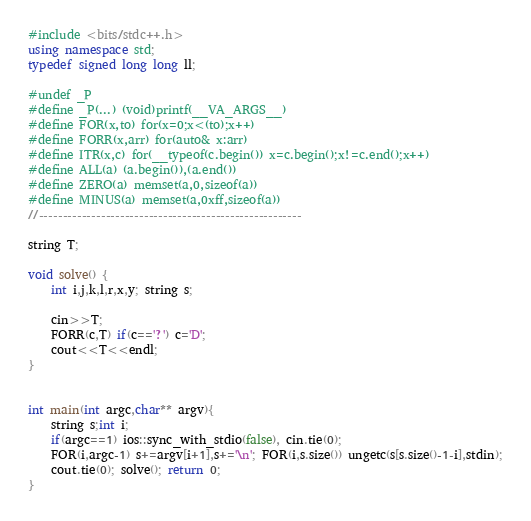Convert code to text. <code><loc_0><loc_0><loc_500><loc_500><_C++_>#include <bits/stdc++.h>
using namespace std;
typedef signed long long ll;

#undef _P
#define _P(...) (void)printf(__VA_ARGS__)
#define FOR(x,to) for(x=0;x<(to);x++)
#define FORR(x,arr) for(auto& x:arr)
#define ITR(x,c) for(__typeof(c.begin()) x=c.begin();x!=c.end();x++)
#define ALL(a) (a.begin()),(a.end())
#define ZERO(a) memset(a,0,sizeof(a))
#define MINUS(a) memset(a,0xff,sizeof(a))
//-------------------------------------------------------

string T;

void solve() {
	int i,j,k,l,r,x,y; string s;
	
	cin>>T;
	FORR(c,T) if(c=='?') c='D';
	cout<<T<<endl;
}


int main(int argc,char** argv){
	string s;int i;
	if(argc==1) ios::sync_with_stdio(false), cin.tie(0);
	FOR(i,argc-1) s+=argv[i+1],s+='\n'; FOR(i,s.size()) ungetc(s[s.size()-1-i],stdin);
	cout.tie(0); solve(); return 0;
}
</code> 